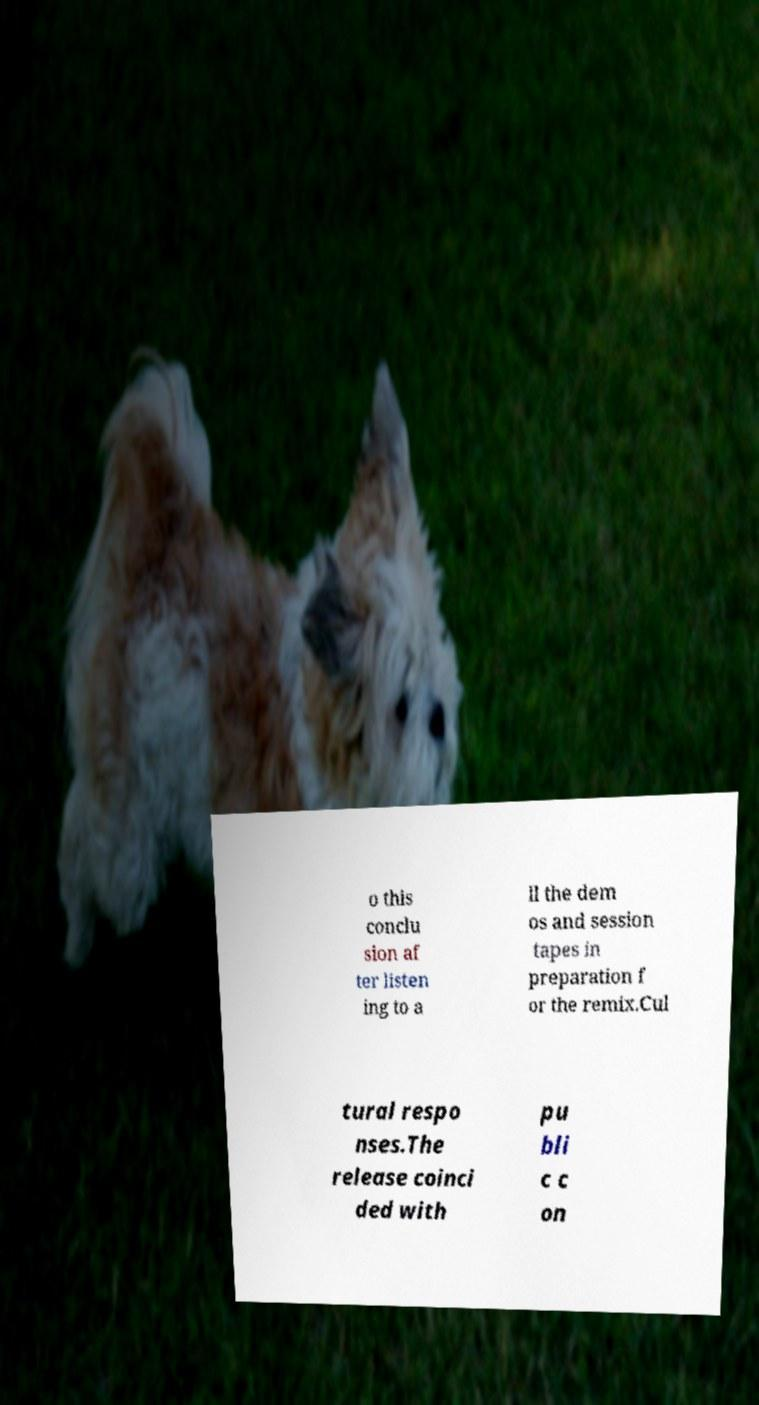Could you assist in decoding the text presented in this image and type it out clearly? o this conclu sion af ter listen ing to a ll the dem os and session tapes in preparation f or the remix.Cul tural respo nses.The release coinci ded with pu bli c c on 